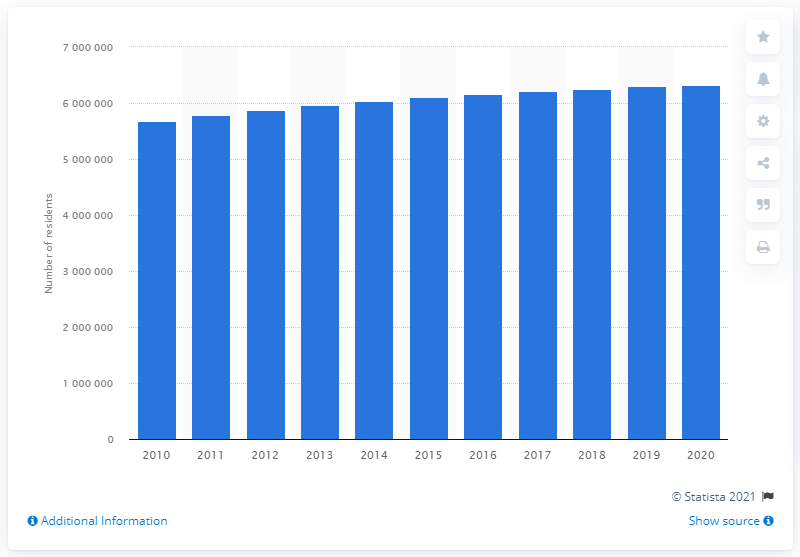Point out several critical features in this image. In 2020, the population of the Washington-Arlington-Alexandria metropolitan area was estimated to be approximately 6297454 people. The population of the Washington-Altington-Alexandria metropolitan area in the previous year was 625,6312. 